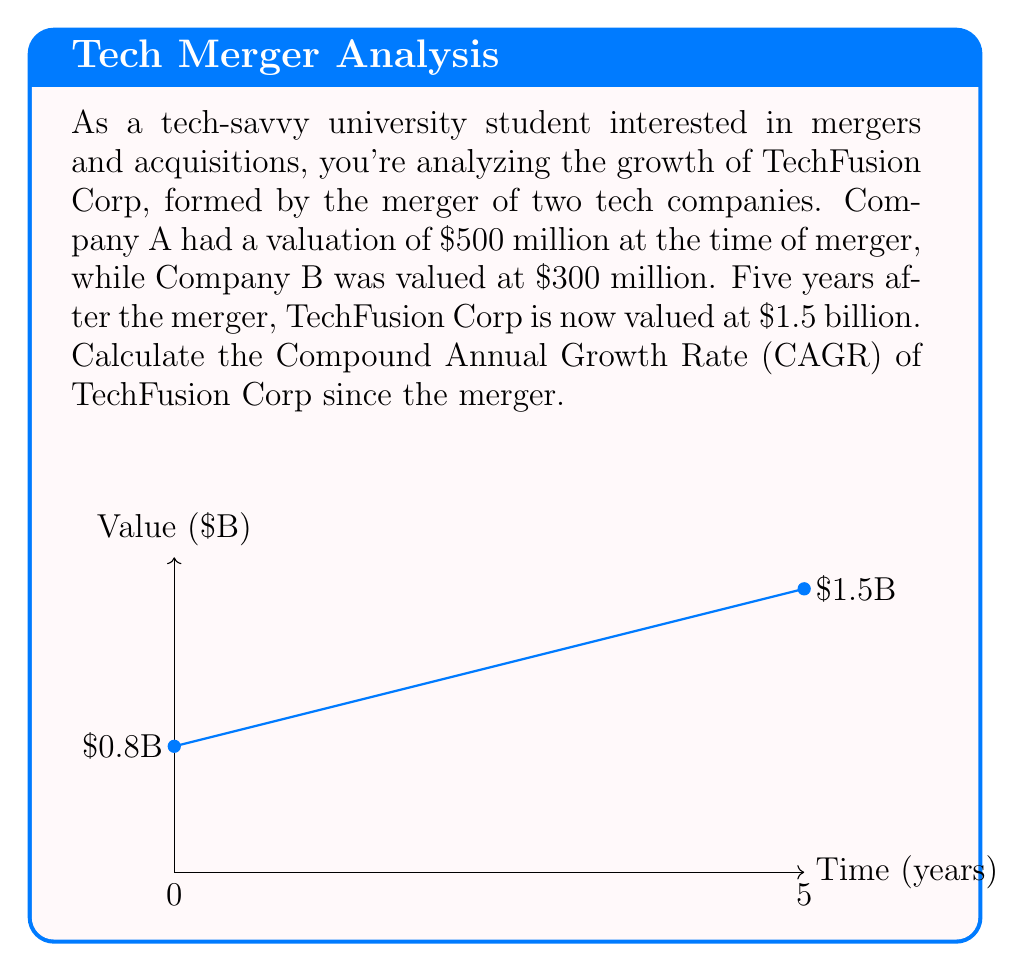Show me your answer to this math problem. To calculate the Compound Annual Growth Rate (CAGR), we'll use the formula:

$$ CAGR = \left(\frac{Ending Value}{Beginning Value}\right)^{\frac{1}{n}} - 1 $$

Where:
- Ending Value = $1.5 billion
- Beginning Value = $500 million + $300 million = $800 million = $0.8 billion
- n = 5 years

Let's plug these values into the formula:

$$ CAGR = \left(\frac{1.5}{0.8}\right)^{\frac{1}{5}} - 1 $$

Now, let's solve step-by-step:

1) First, calculate the fraction inside the parentheses:
   $\frac{1.5}{0.8} = 1.875$

2) Now, our equation looks like this:
   $CAGR = (1.875)^{\frac{1}{5}} - 1$

3) Calculate the fifth root of 1.875:
   $(1.875)^{\frac{1}{5}} \approx 1.1338$

4) Subtract 1:
   $1.1338 - 1 = 0.1338$

5) Convert to a percentage:
   $0.1338 \times 100 = 13.38\%$

Therefore, the Compound Annual Growth Rate of TechFusion Corp since the merger is approximately 13.38%.
Answer: 13.38% 